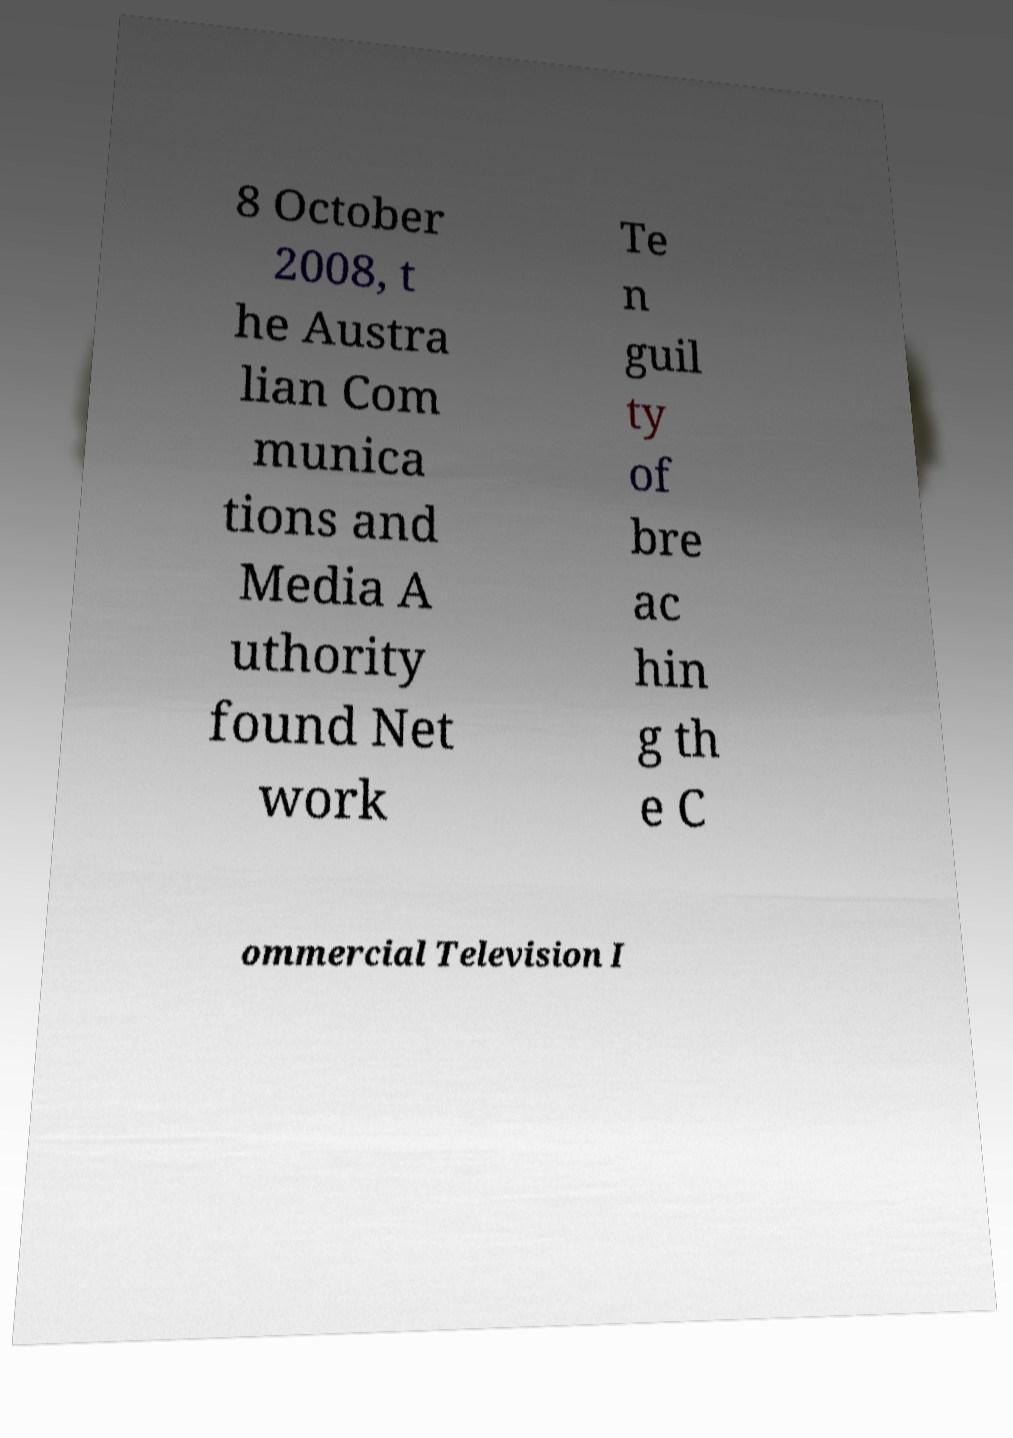What messages or text are displayed in this image? I need them in a readable, typed format. 8 October 2008, t he Austra lian Com munica tions and Media A uthority found Net work Te n guil ty of bre ac hin g th e C ommercial Television I 